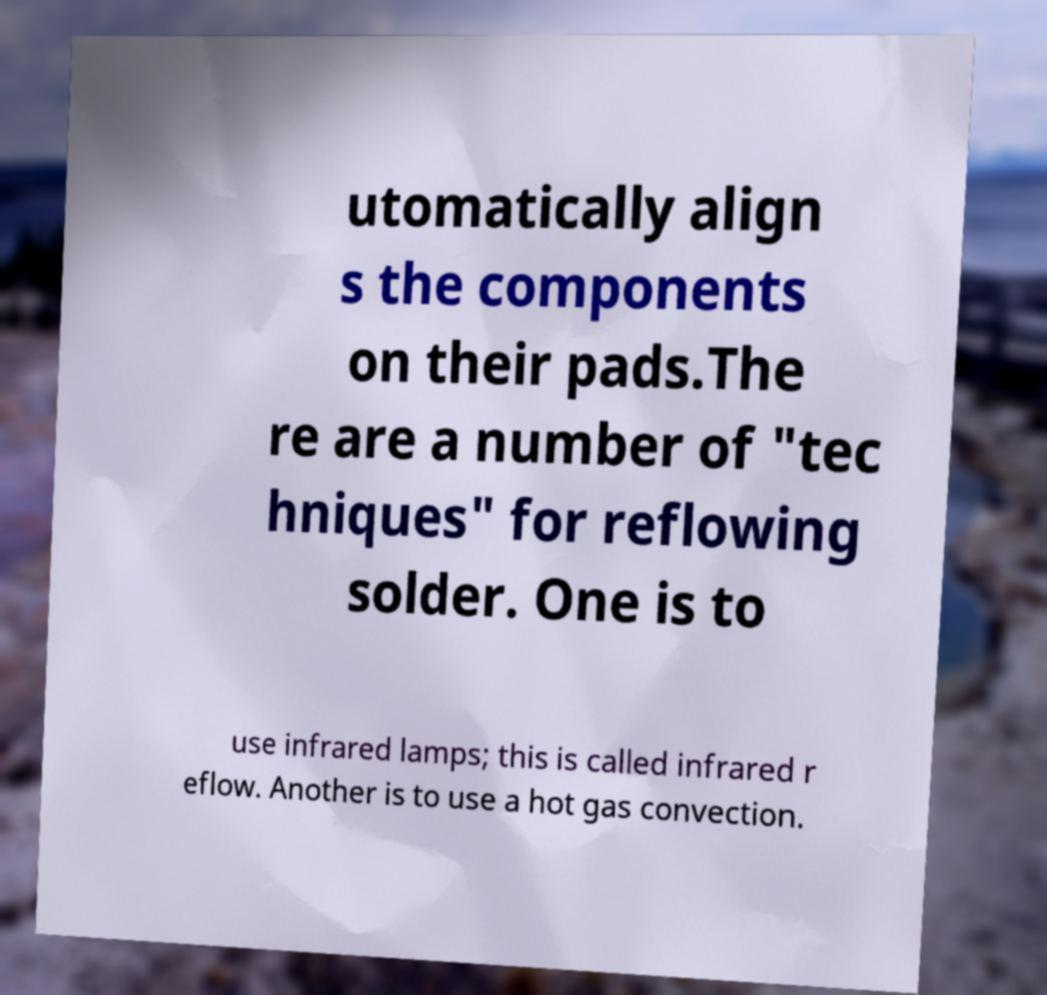Please identify and transcribe the text found in this image. utomatically align s the components on their pads.The re are a number of "tec hniques" for reflowing solder. One is to use infrared lamps; this is called infrared r eflow. Another is to use a hot gas convection. 